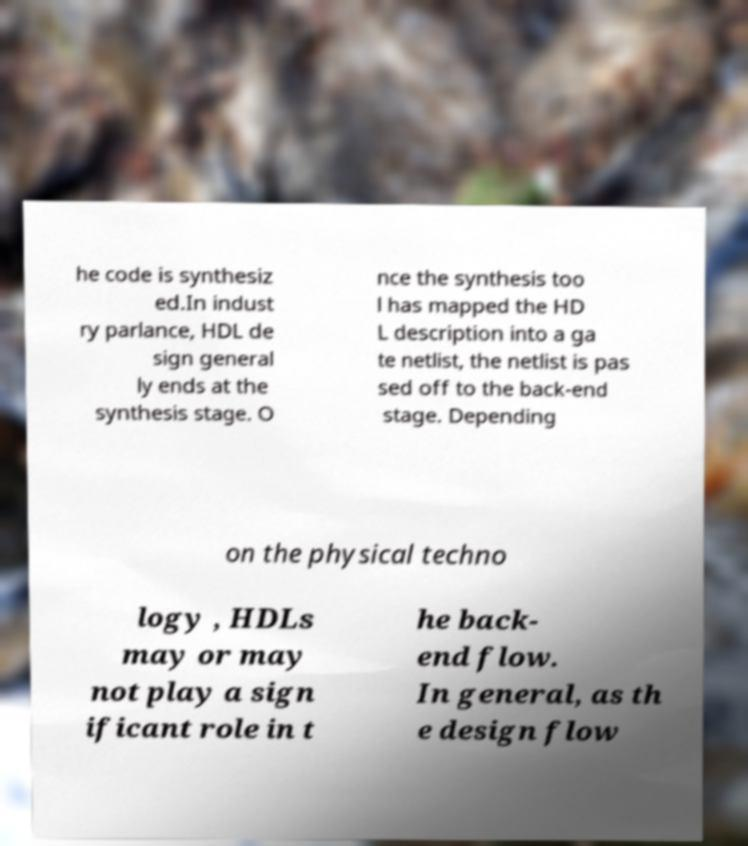Could you extract and type out the text from this image? he code is synthesiz ed.In indust ry parlance, HDL de sign general ly ends at the synthesis stage. O nce the synthesis too l has mapped the HD L description into a ga te netlist, the netlist is pas sed off to the back-end stage. Depending on the physical techno logy , HDLs may or may not play a sign ificant role in t he back- end flow. In general, as th e design flow 